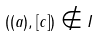Convert formula to latex. <formula><loc_0><loc_0><loc_500><loc_500>( ( a ) , [ c ] ) \notin I</formula> 